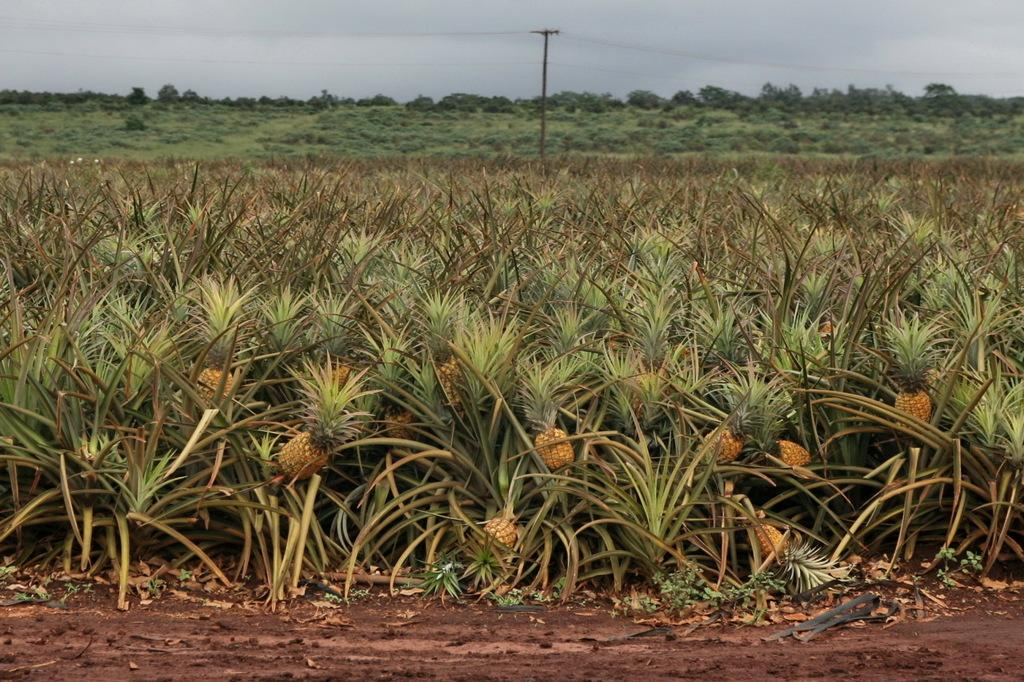What type of plants can be seen on the path in the image? There are pineapple plants on the path in the image. What is located behind the plants? There is an electric pole with cables behind the plants. What else can be seen in the background of the image? Trees are visible behind the plants. How would you describe the sky in the image? The sky is cloudy in the image. Can you see any dolls playing chess on the path in the image? There are no dolls or chess games present in the image; it features pineapple plants on a path with an electric pole and trees in the background. 